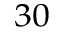Convert formula to latex. <formula><loc_0><loc_0><loc_500><loc_500>^ { 3 0 }</formula> 